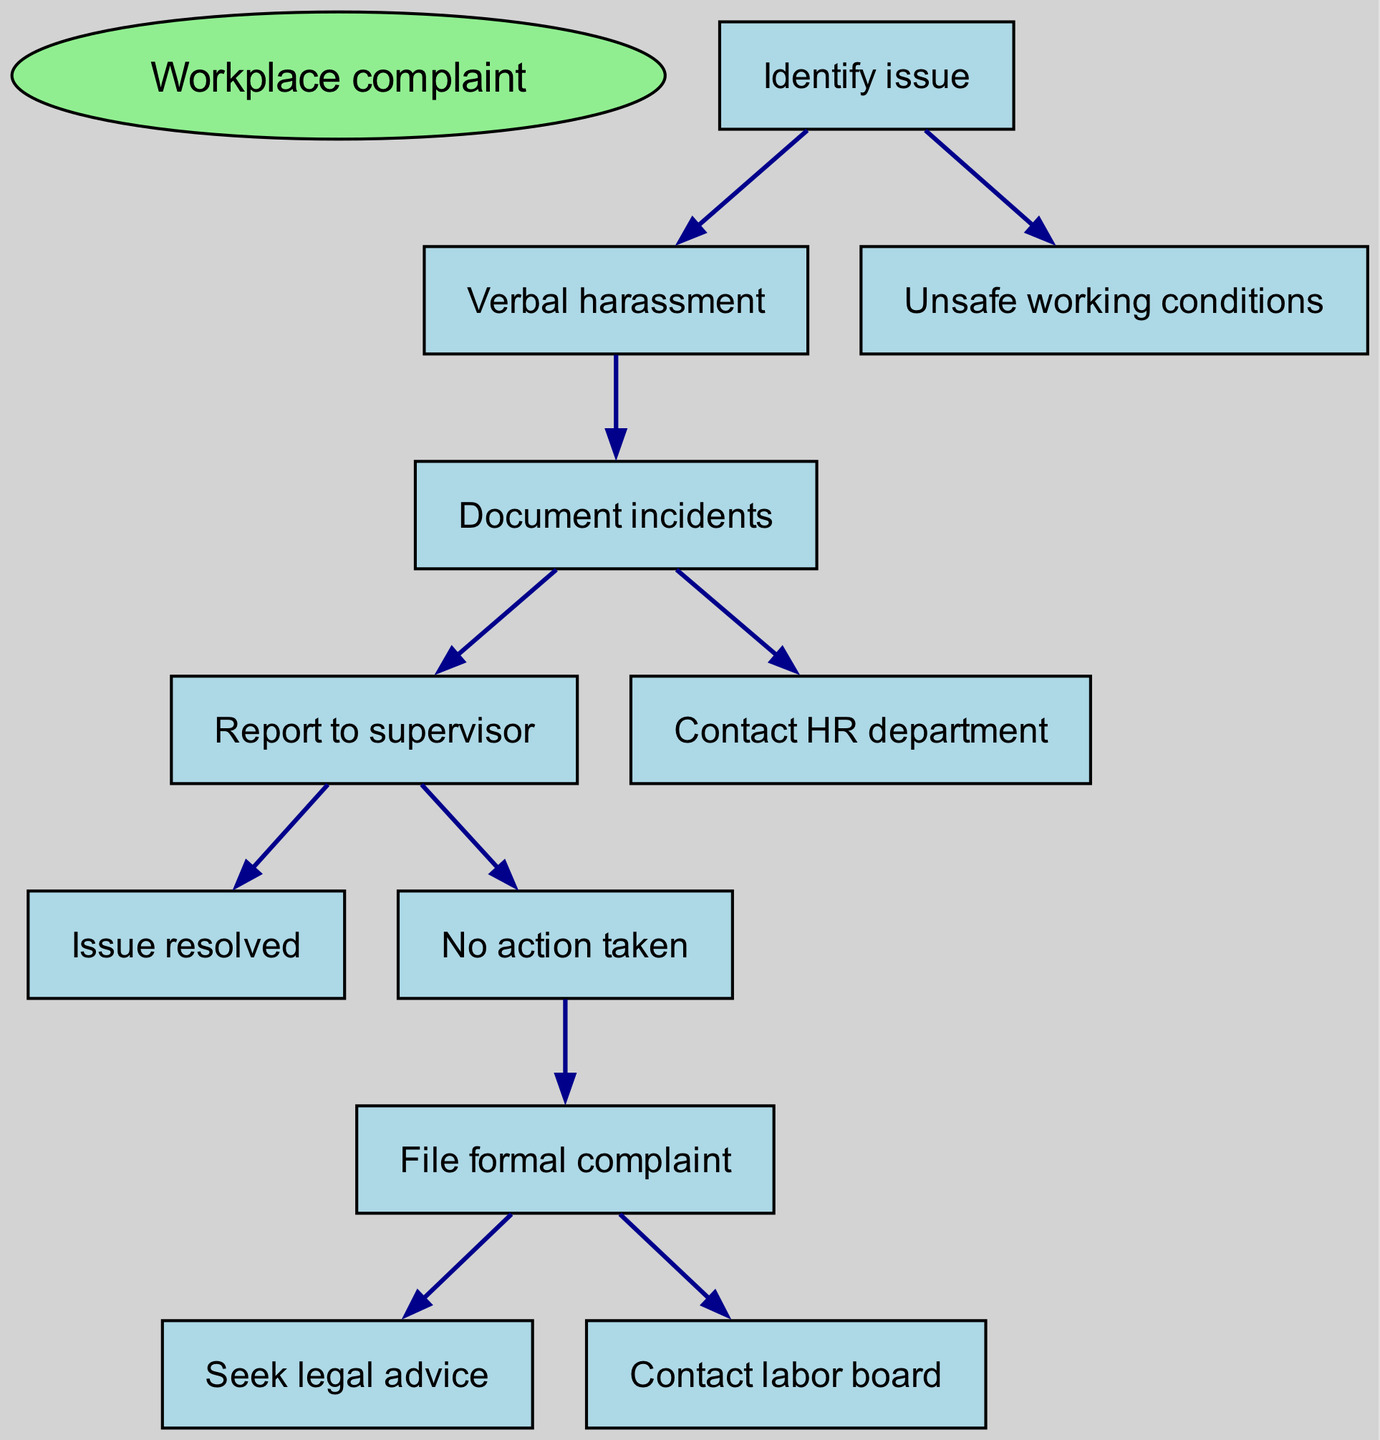What is the root node of the diagram? The root node is the starting point of the diagram, which is "Workplace complaint."
Answer: Workplace complaint How many child nodes does "Identify issue" have? The "Identify issue" node has two child nodes: "Verbal harassment" and "Unsafe working conditions."
Answer: 2 What is the node that represents documenting incidents? The node that represents documenting incidents is "Document incidents."
Answer: Document incidents Which node follows "Contact HR department"? The "Contact HR department" node leads to two potential outcomes: "Issue resolved" and "No action taken." Both "Issue resolved" and "No action taken" follow it.
Answer: Issue resolved, No action taken What happens if "No action taken" occurs after reporting? If "No action taken" occurs, the next step is to "File formal complaint."
Answer: File formal complaint What is the final step after filing a formal complaint? After filing a formal complaint, there are two final steps: "Seek legal advice" and "Contact labor board."
Answer: Seek legal advice, Contact labor board How many nodes lead directly to "Issue resolved"? Only one node, "Report to supervisor," leads directly to "Issue resolved."
Answer: 1 What does the diagram illustrate? The diagram illustrates the process of filing a workplace complaint.
Answer: filing a workplace complaint Which node indicates the first action to take? The first action indicated in the diagram is "Identify issue."
Answer: Identify issue 